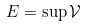Convert formula to latex. <formula><loc_0><loc_0><loc_500><loc_500>E = \sup \mathcal { V }</formula> 